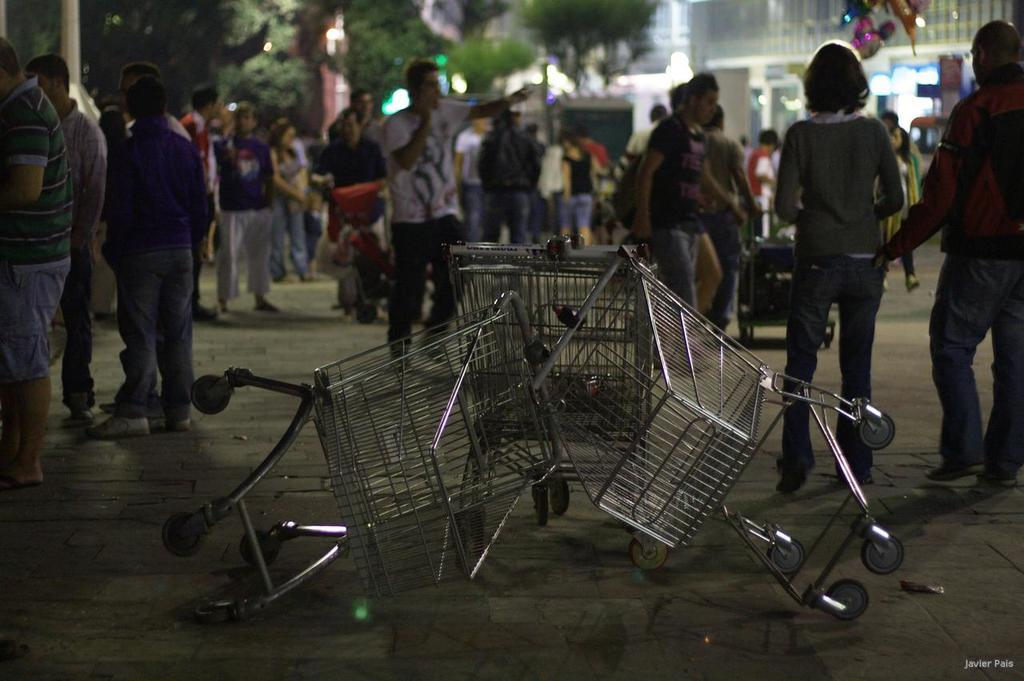What type of shopping trolleys can be seen on the ground in the image? There are silver-colored shopping trolleys on the ground. What is the gender distribution of the people standing outside the mall? There are many men and women standing outside the mall. What is located behind the people in the image? There is a building behind the people. What type of vegetation can be seen behind the building? There are trees visible behind the building. Where is the cannon located in the image? There is no cannon present in the image. How many rabbits can be seen hopping around the shopping trolleys? There are no rabbits present in the image; it only features shopping trolleys, people, a building, and trees. 